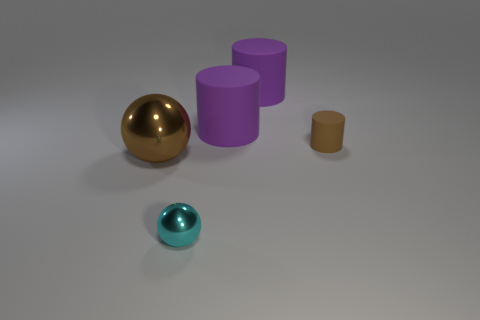Does the brown ball have the same size as the cyan shiny sphere?
Your answer should be very brief. No. How many things are either gray cylinders or things that are in front of the brown cylinder?
Ensure brevity in your answer.  2. What is the small cyan ball made of?
Make the answer very short. Metal. Is there any other thing of the same color as the small cylinder?
Make the answer very short. Yes. Do the large metallic object and the tiny cyan metallic object have the same shape?
Provide a short and direct response. Yes. What is the size of the shiny sphere that is to the left of the metal object that is to the right of the brown object that is to the left of the small brown matte thing?
Ensure brevity in your answer.  Large. How many other things are there of the same material as the small cyan thing?
Offer a terse response. 1. What color is the tiny object that is to the left of the tiny cylinder?
Provide a short and direct response. Cyan. What is the material of the ball left of the ball in front of the object on the left side of the small metallic sphere?
Your answer should be very brief. Metal. Are there any other small things that have the same shape as the small matte object?
Your answer should be very brief. No. 